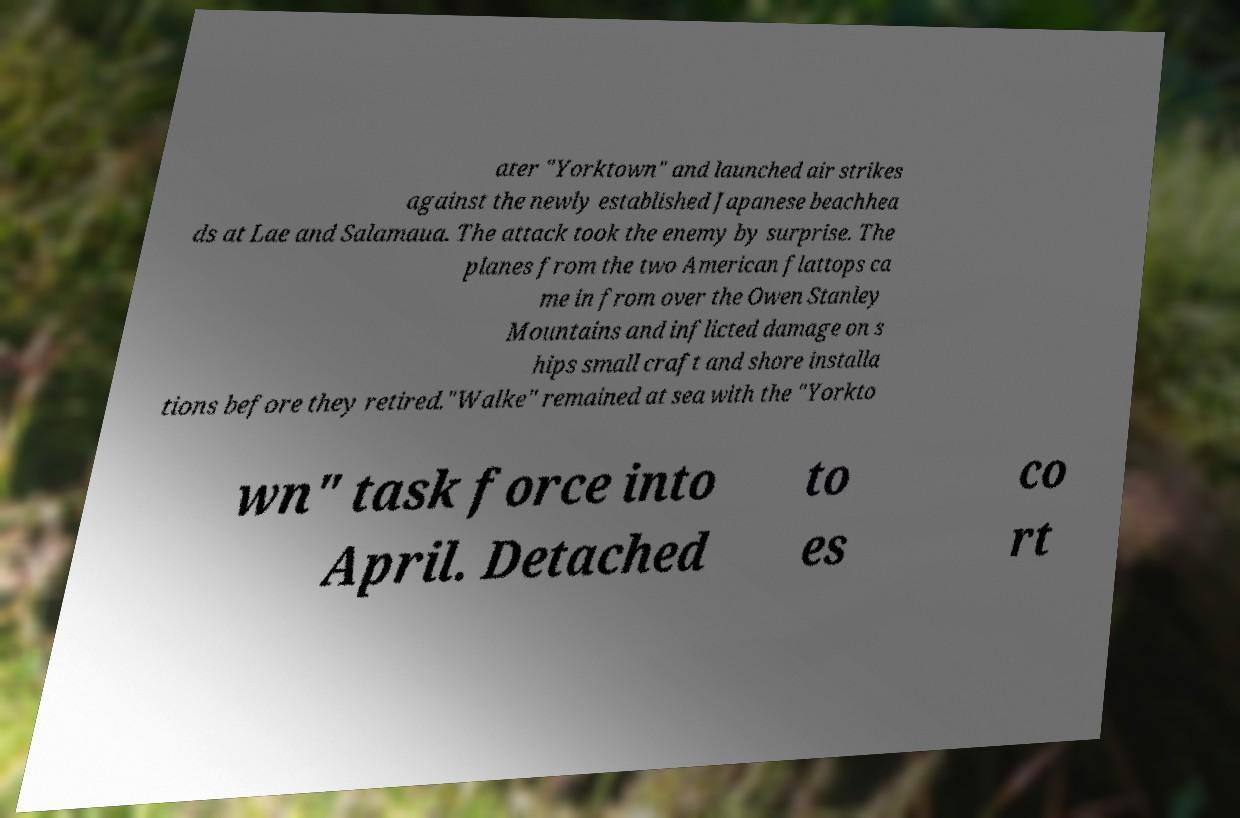I need the written content from this picture converted into text. Can you do that? ater "Yorktown" and launched air strikes against the newly established Japanese beachhea ds at Lae and Salamaua. The attack took the enemy by surprise. The planes from the two American flattops ca me in from over the Owen Stanley Mountains and inflicted damage on s hips small craft and shore installa tions before they retired."Walke" remained at sea with the "Yorkto wn" task force into April. Detached to es co rt 